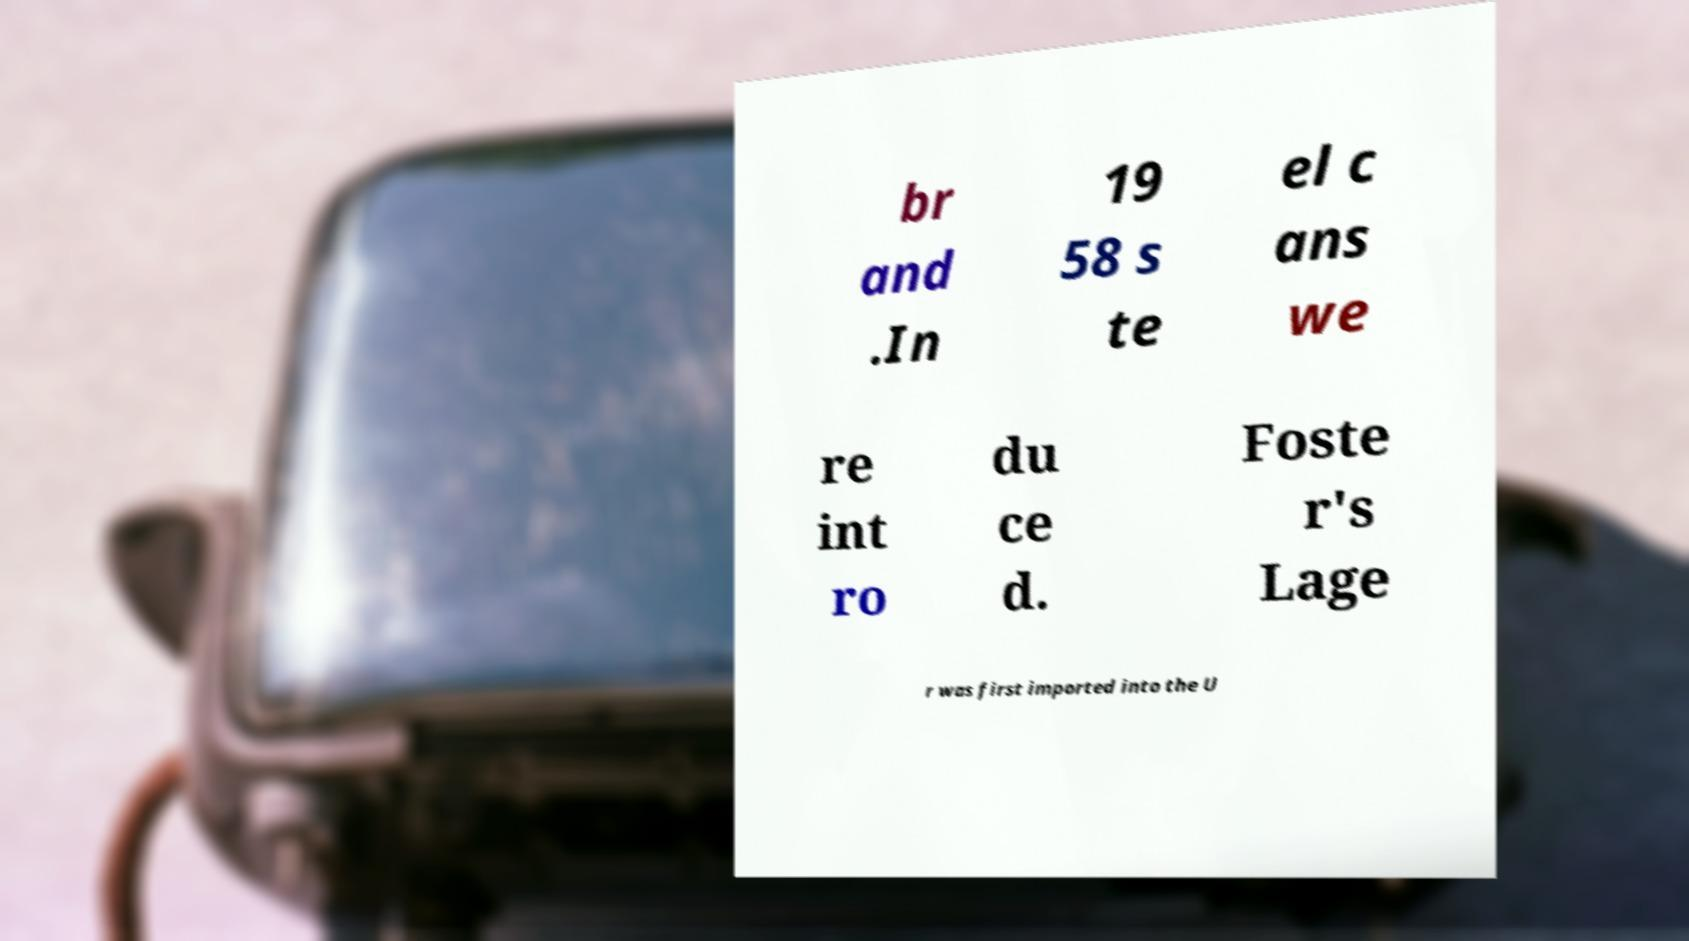Please read and relay the text visible in this image. What does it say? br and .In 19 58 s te el c ans we re int ro du ce d. Foste r's Lage r was first imported into the U 